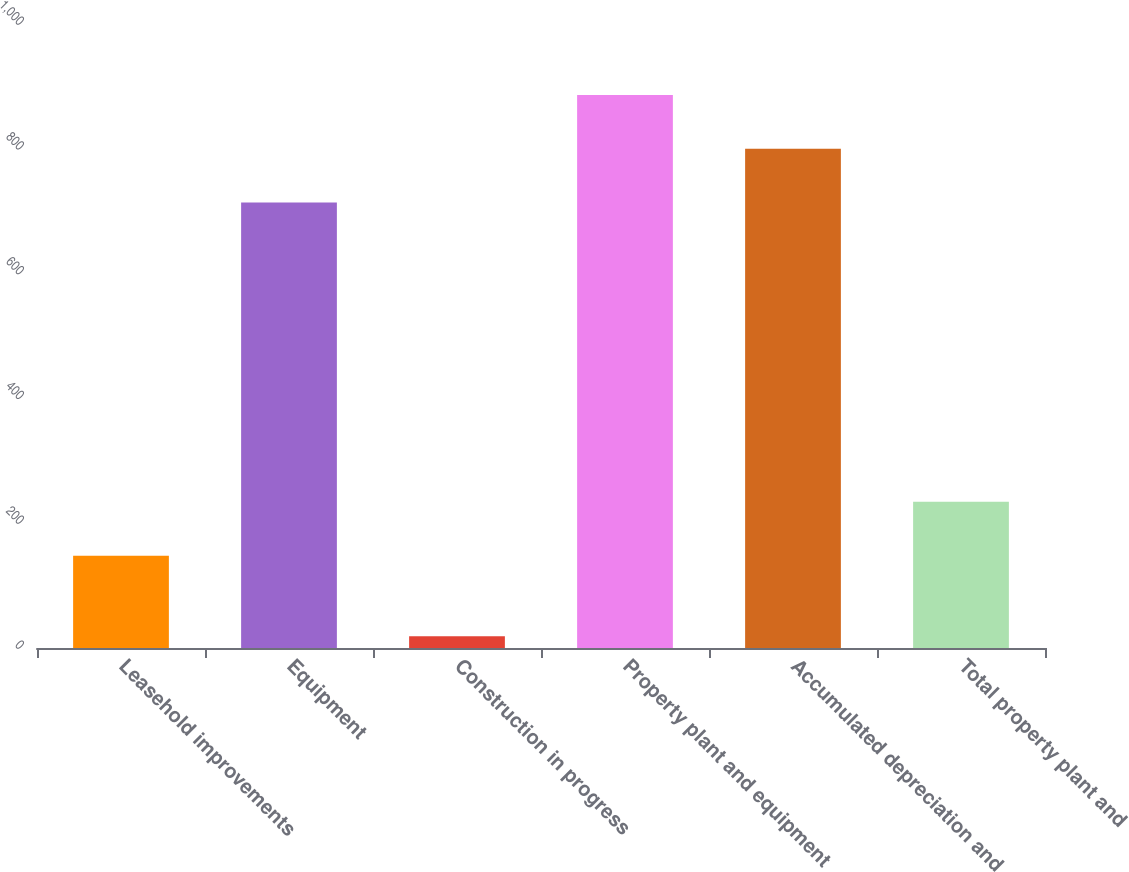<chart> <loc_0><loc_0><loc_500><loc_500><bar_chart><fcel>Leasehold improvements<fcel>Equipment<fcel>Construction in progress<fcel>Property plant and equipment<fcel>Accumulated depreciation and<fcel>Total property plant and<nl><fcel>148<fcel>714<fcel>19<fcel>886.4<fcel>800.2<fcel>234.2<nl></chart> 